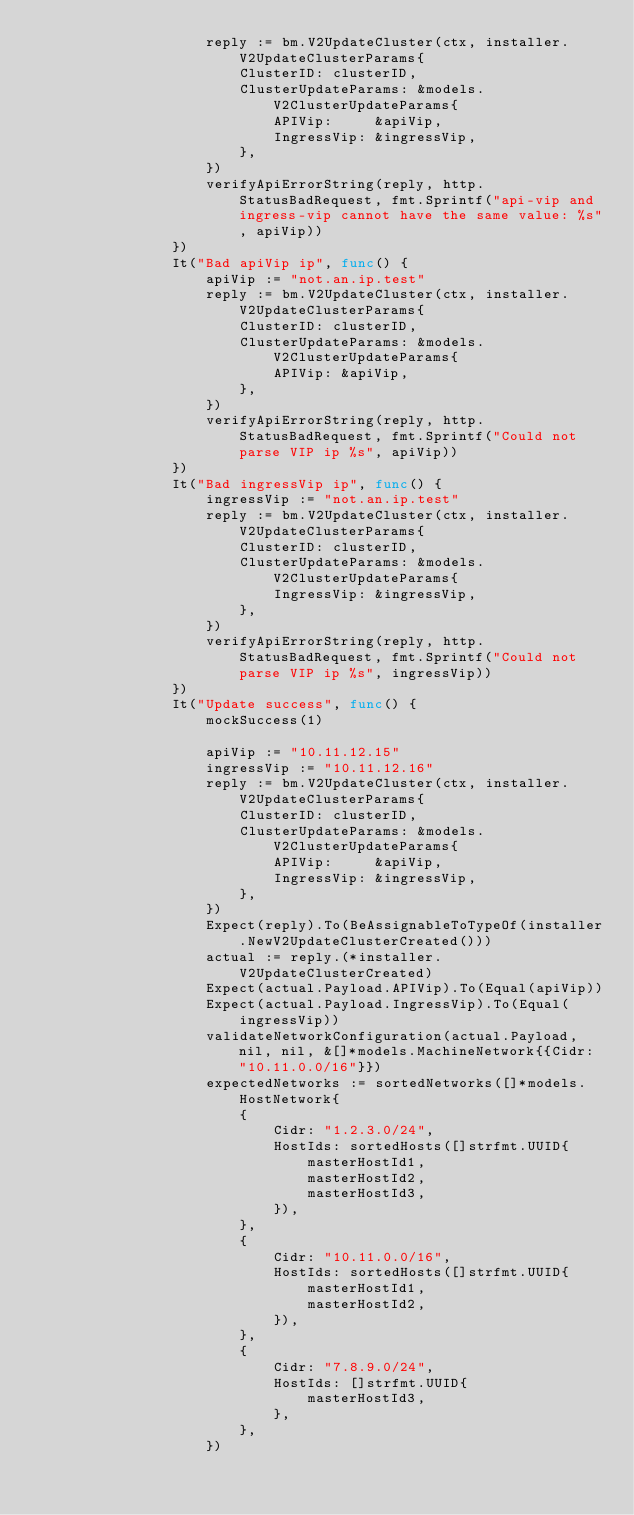Convert code to text. <code><loc_0><loc_0><loc_500><loc_500><_Go_>					reply := bm.V2UpdateCluster(ctx, installer.V2UpdateClusterParams{
						ClusterID: clusterID,
						ClusterUpdateParams: &models.V2ClusterUpdateParams{
							APIVip:     &apiVip,
							IngressVip: &ingressVip,
						},
					})
					verifyApiErrorString(reply, http.StatusBadRequest, fmt.Sprintf("api-vip and ingress-vip cannot have the same value: %s", apiVip))
				})
				It("Bad apiVip ip", func() {
					apiVip := "not.an.ip.test"
					reply := bm.V2UpdateCluster(ctx, installer.V2UpdateClusterParams{
						ClusterID: clusterID,
						ClusterUpdateParams: &models.V2ClusterUpdateParams{
							APIVip: &apiVip,
						},
					})
					verifyApiErrorString(reply, http.StatusBadRequest, fmt.Sprintf("Could not parse VIP ip %s", apiVip))
				})
				It("Bad ingressVip ip", func() {
					ingressVip := "not.an.ip.test"
					reply := bm.V2UpdateCluster(ctx, installer.V2UpdateClusterParams{
						ClusterID: clusterID,
						ClusterUpdateParams: &models.V2ClusterUpdateParams{
							IngressVip: &ingressVip,
						},
					})
					verifyApiErrorString(reply, http.StatusBadRequest, fmt.Sprintf("Could not parse VIP ip %s", ingressVip))
				})
				It("Update success", func() {
					mockSuccess(1)

					apiVip := "10.11.12.15"
					ingressVip := "10.11.12.16"
					reply := bm.V2UpdateCluster(ctx, installer.V2UpdateClusterParams{
						ClusterID: clusterID,
						ClusterUpdateParams: &models.V2ClusterUpdateParams{
							APIVip:     &apiVip,
							IngressVip: &ingressVip,
						},
					})
					Expect(reply).To(BeAssignableToTypeOf(installer.NewV2UpdateClusterCreated()))
					actual := reply.(*installer.V2UpdateClusterCreated)
					Expect(actual.Payload.APIVip).To(Equal(apiVip))
					Expect(actual.Payload.IngressVip).To(Equal(ingressVip))
					validateNetworkConfiguration(actual.Payload, nil, nil, &[]*models.MachineNetwork{{Cidr: "10.11.0.0/16"}})
					expectedNetworks := sortedNetworks([]*models.HostNetwork{
						{
							Cidr: "1.2.3.0/24",
							HostIds: sortedHosts([]strfmt.UUID{
								masterHostId1,
								masterHostId2,
								masterHostId3,
							}),
						},
						{
							Cidr: "10.11.0.0/16",
							HostIds: sortedHosts([]strfmt.UUID{
								masterHostId1,
								masterHostId2,
							}),
						},
						{
							Cidr: "7.8.9.0/24",
							HostIds: []strfmt.UUID{
								masterHostId3,
							},
						},
					})</code> 